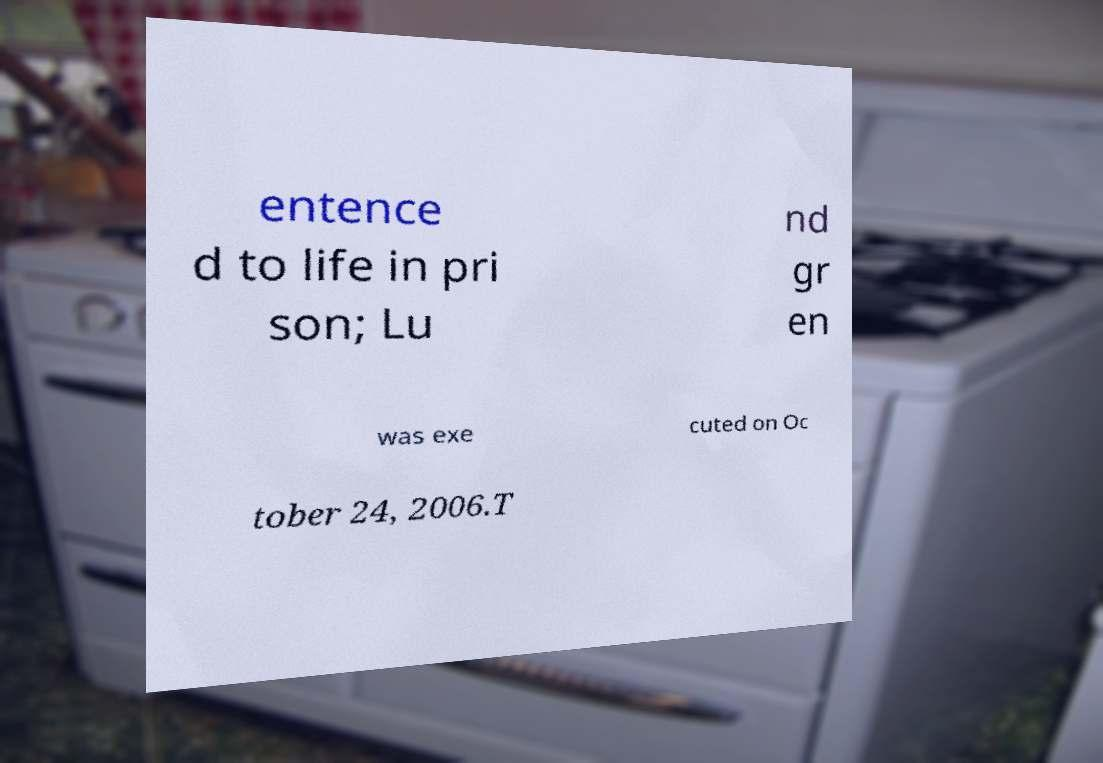I need the written content from this picture converted into text. Can you do that? entence d to life in pri son; Lu nd gr en was exe cuted on Oc tober 24, 2006.T 